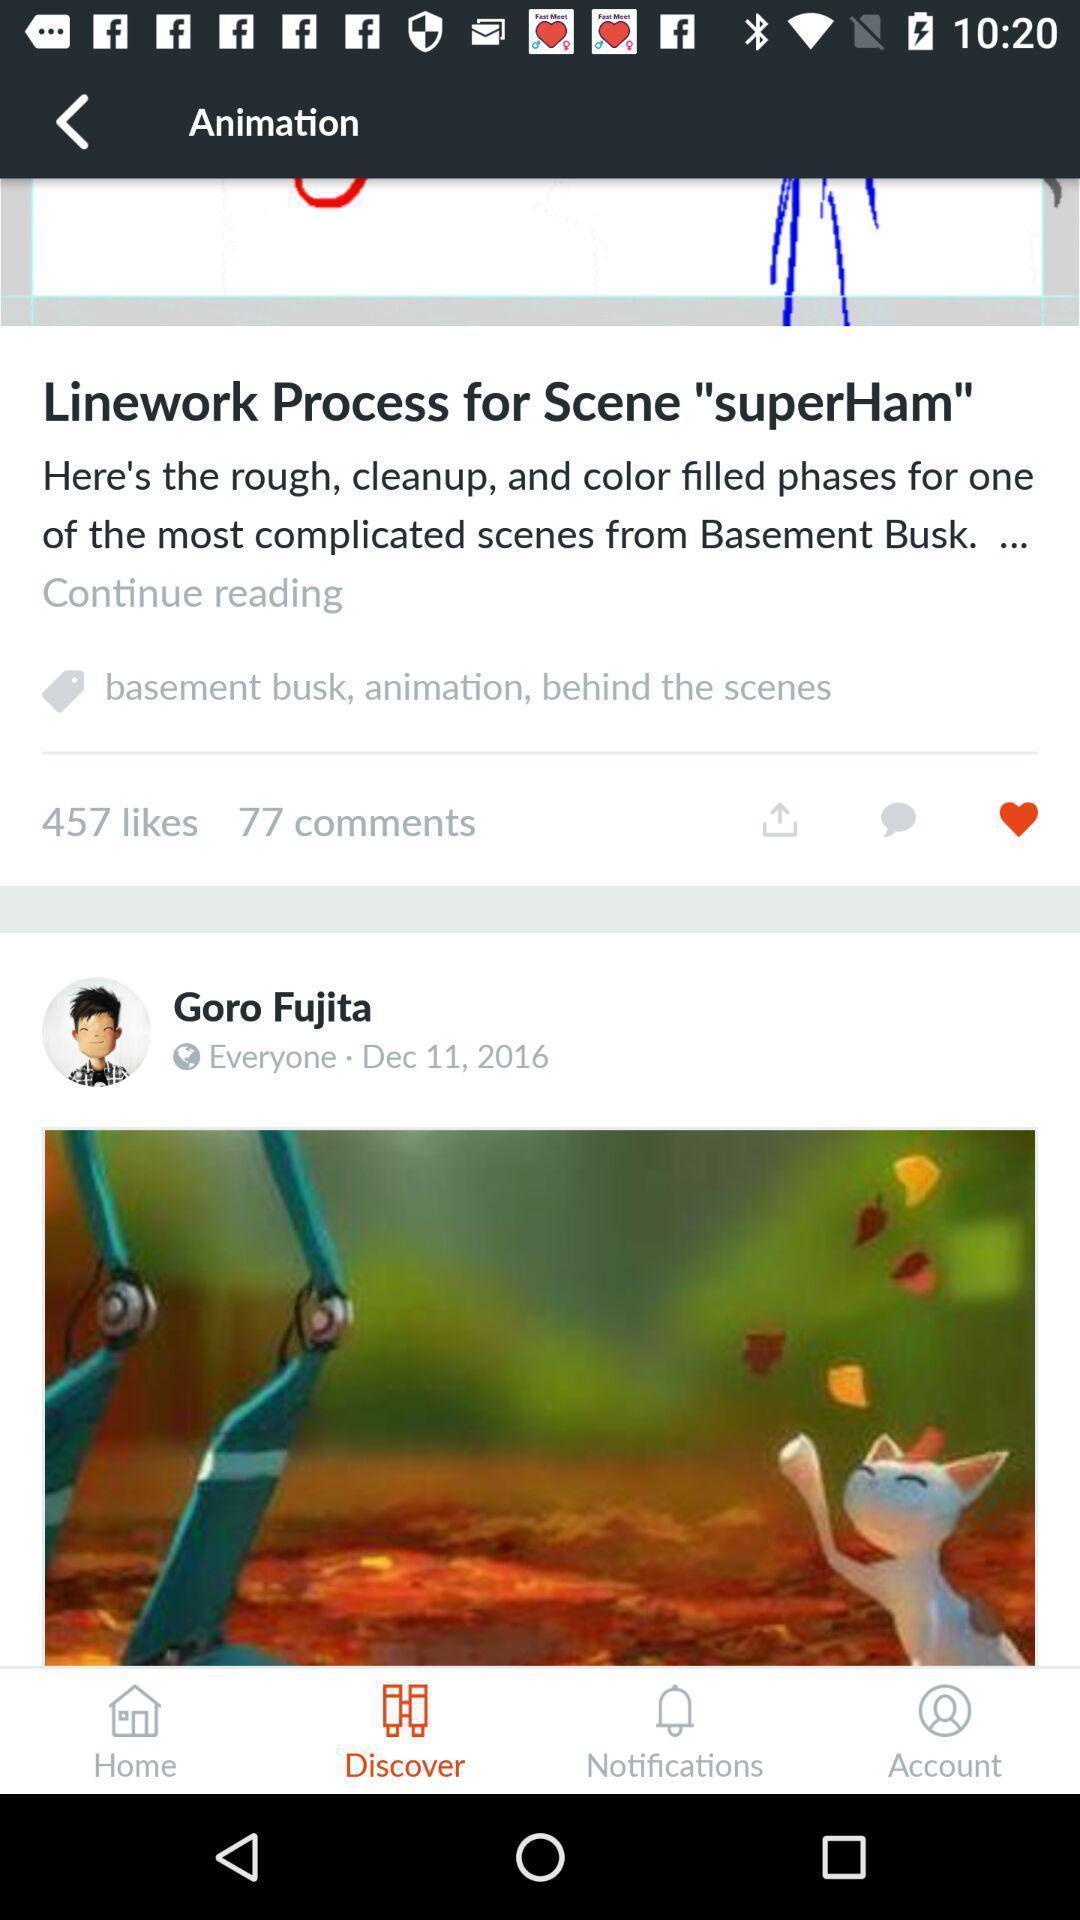What can you discern from this picture? Screen showing animation with likes and comments. 